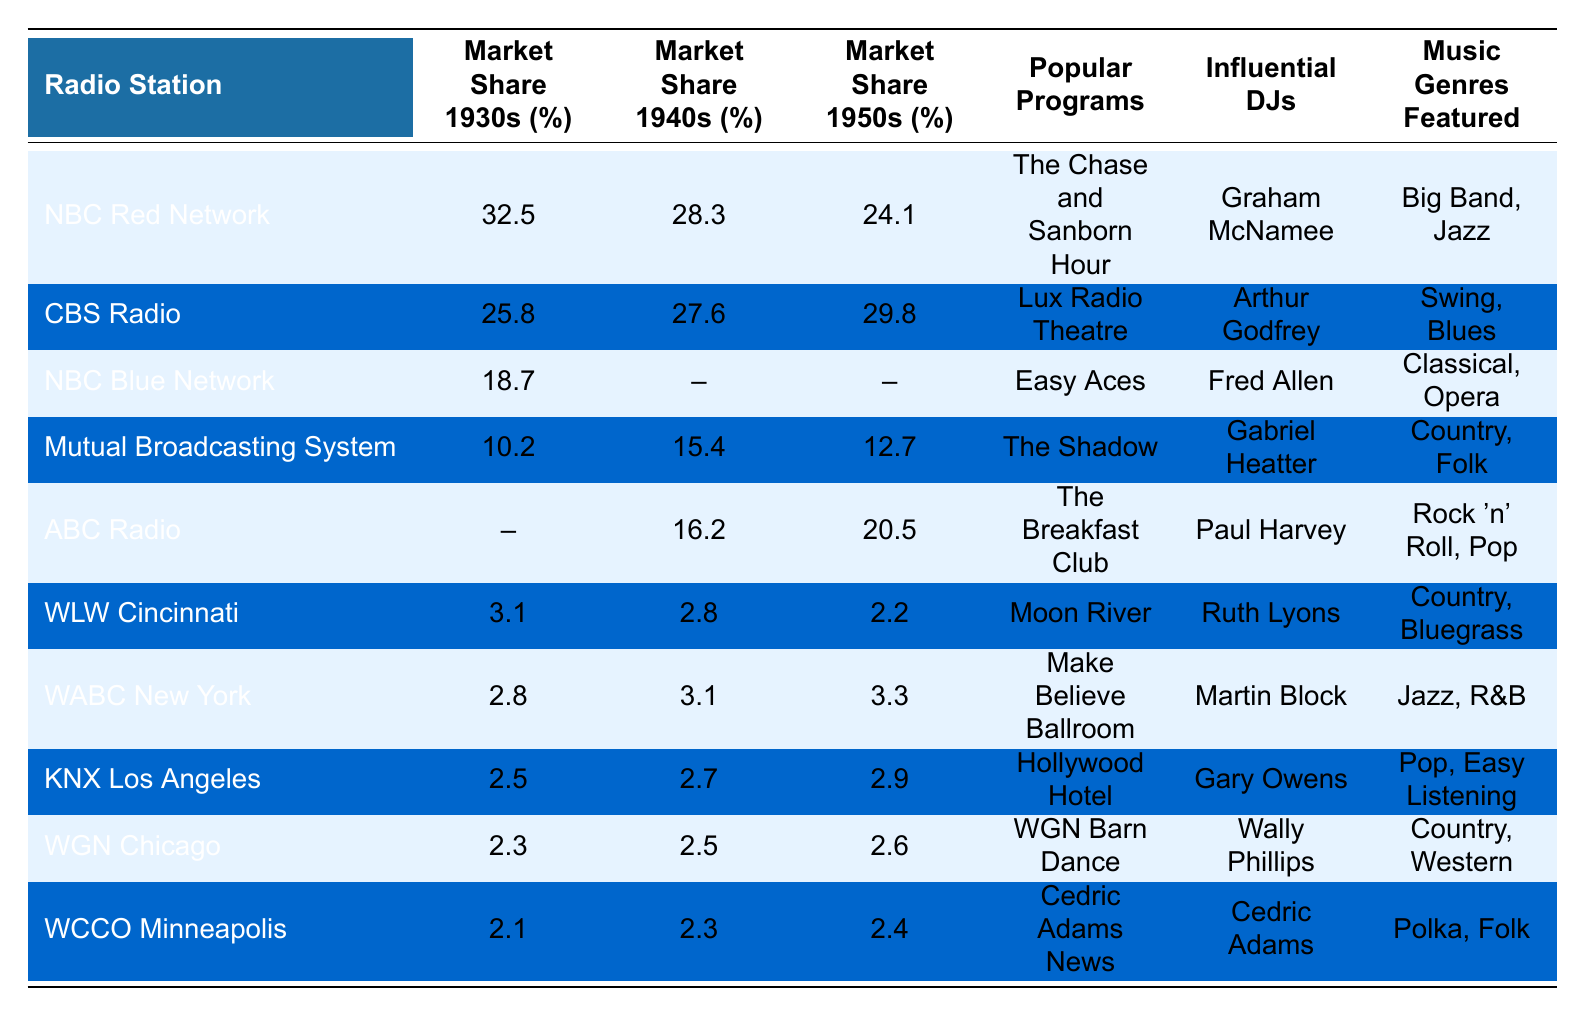What was the market share of NBC Red Network in the 1930s? From the table, the market share percentage for NBC Red Network during the 1930s is stated as 32.5%.
Answer: 32.5% Which radio station had the highest market share in the 1940s? By comparing the market share percentages for the 1940s for all radio stations, CBS Radio has the highest percentage at 27.6%.
Answer: CBS Radio Did NBC Blue Network have a market share recorded in the 1940s and 1950s? The table indicates that there is no recorded market share for NBC Blue Network in both the 1940s and 1950s, as it shows null values for those decades.
Answer: No What is the difference in market share for CBS Radio from the 1930s to the 1950s? CBS Radio's market share in the 1930s was 25.8% and in the 1950s it was 29.8%. The difference is 29.8% - 25.8% = 4%.
Answer: 4% Which radio station consistently had the lowest market share across all three decades? By examining the market share across the decades, WLW Cincinnati had the lowest percentages in the 1930s (3.1%), 1940s (2.8%), and 1950s (2.2%), indicating consistency in being the lowest.
Answer: WLW Cincinnati How much did the market share for ABC Radio increase from the 1940s to the 1950s? ABC Radio had a market share of 16.2% in the 1940s and increased to 20.5% in the 1950s. The increase is 20.5% - 16.2% = 4.3%.
Answer: 4.3% What were the top three music genres featured by the radio stations in the table? From the “Music Genres Featured” column, the top three genres are Big Band, Jazz from NBC Red Network; Swing, Blues from CBS Radio; and Classical, Opera from NBC Blue Network.
Answer: Big Band, Jazz; Swing, Blues; Classical, Opera Which influential DJ is associated with the program "The Shadow"? The table associates the program "The Shadow" with the influential DJ Gabriel Heatter.
Answer: Gabriel Heatter Calculate the average market share for WGN Chicago over the three decades. The market shares are 2.3% in the 1930s, 2.5% in the 1940s, and 2.6% in the 1950s. The total is 2.3% + 2.5% + 2.6% = 7.4%. Dividing by 3 gives an average of 7.4% / 3 = 2.47%.
Answer: 2.47% Is there any radio station that had a market share above 30% at any time during these decades? By checking the market share values, only NBC Red Network had a market share above 30%, specifically 32.5% in the 1930s.
Answer: Yes What was the popular program for WLW Cincinnati? According to the table, the popular program for WLW Cincinnati was "Moon River."
Answer: Moon River 